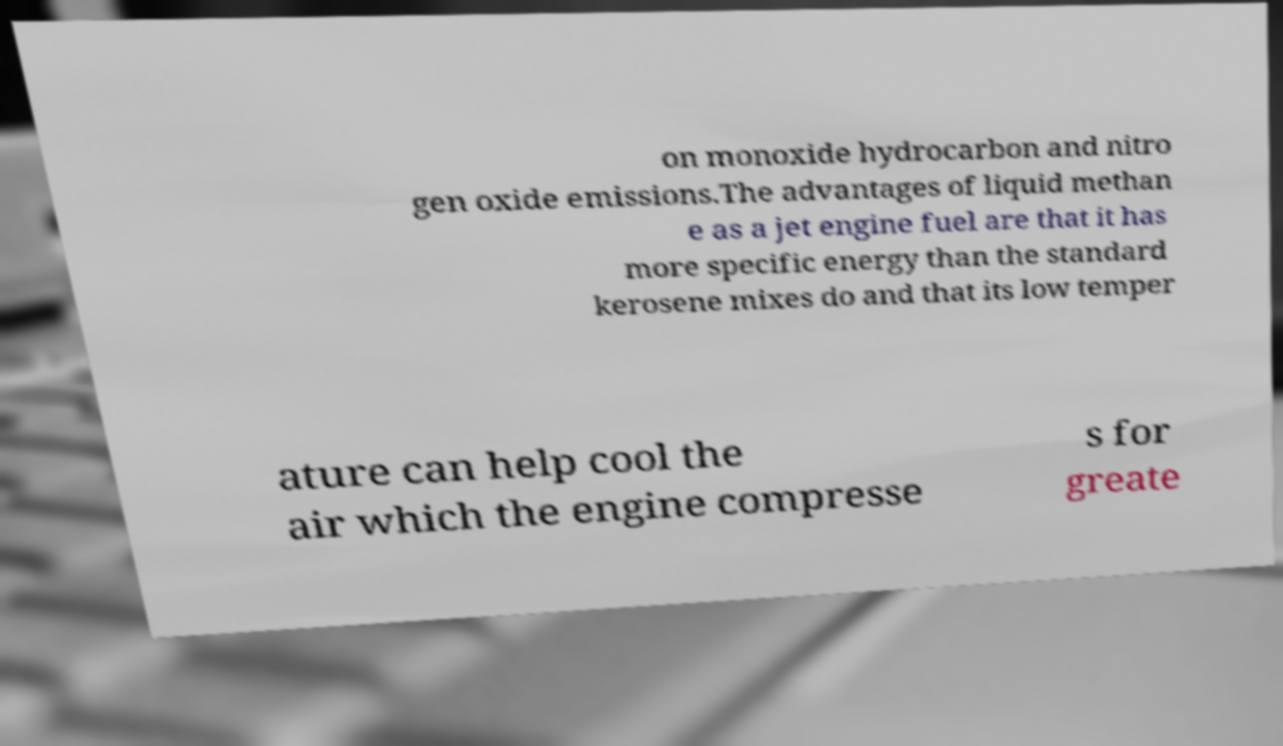Could you extract and type out the text from this image? on monoxide hydrocarbon and nitro gen oxide emissions.The advantages of liquid methan e as a jet engine fuel are that it has more specific energy than the standard kerosene mixes do and that its low temper ature can help cool the air which the engine compresse s for greate 